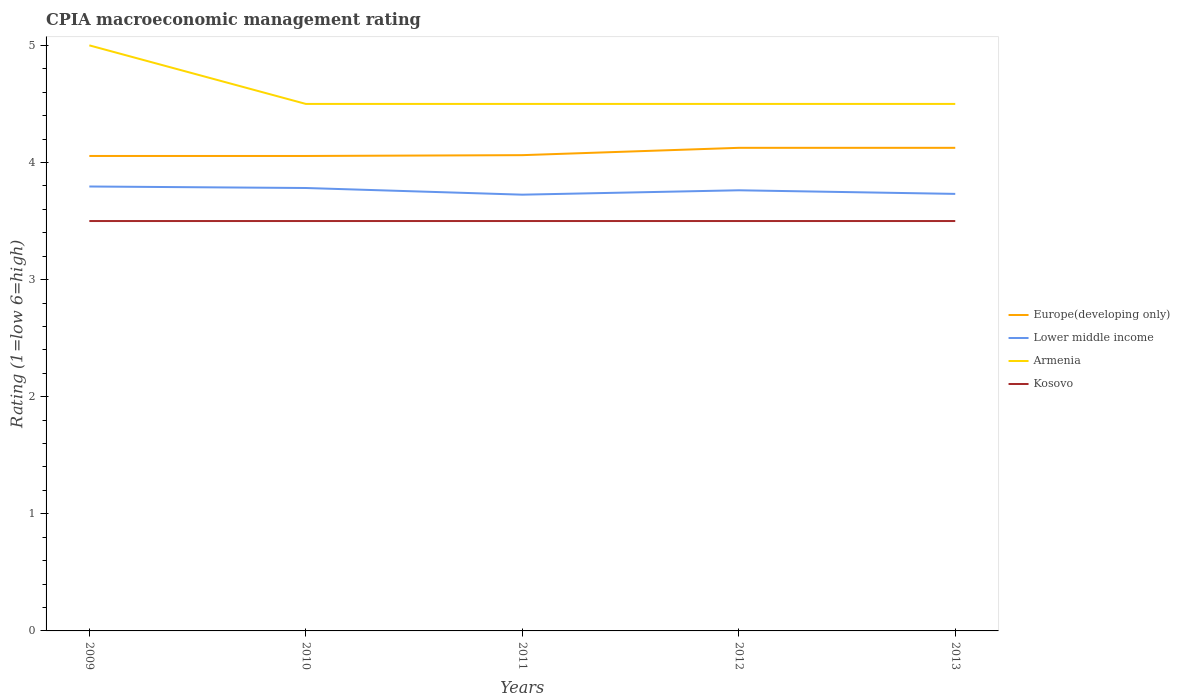Does the line corresponding to Kosovo intersect with the line corresponding to Lower middle income?
Provide a succinct answer. No. Is the number of lines equal to the number of legend labels?
Keep it short and to the point. Yes. Across all years, what is the maximum CPIA rating in Lower middle income?
Offer a terse response. 3.73. What is the difference between the highest and the second highest CPIA rating in Europe(developing only)?
Your response must be concise. 0.07. How many lines are there?
Your answer should be compact. 4. How many years are there in the graph?
Your answer should be very brief. 5. What is the difference between two consecutive major ticks on the Y-axis?
Give a very brief answer. 1. Are the values on the major ticks of Y-axis written in scientific E-notation?
Make the answer very short. No. Does the graph contain any zero values?
Offer a terse response. No. Does the graph contain grids?
Give a very brief answer. No. Where does the legend appear in the graph?
Give a very brief answer. Center right. What is the title of the graph?
Keep it short and to the point. CPIA macroeconomic management rating. What is the label or title of the Y-axis?
Your answer should be compact. Rating (1=low 6=high). What is the Rating (1=low 6=high) in Europe(developing only) in 2009?
Provide a succinct answer. 4.06. What is the Rating (1=low 6=high) of Lower middle income in 2009?
Your answer should be compact. 3.79. What is the Rating (1=low 6=high) of Europe(developing only) in 2010?
Keep it short and to the point. 4.06. What is the Rating (1=low 6=high) of Lower middle income in 2010?
Your answer should be compact. 3.78. What is the Rating (1=low 6=high) in Europe(developing only) in 2011?
Ensure brevity in your answer.  4.06. What is the Rating (1=low 6=high) in Lower middle income in 2011?
Your response must be concise. 3.73. What is the Rating (1=low 6=high) in Armenia in 2011?
Your response must be concise. 4.5. What is the Rating (1=low 6=high) of Europe(developing only) in 2012?
Your answer should be compact. 4.12. What is the Rating (1=low 6=high) in Lower middle income in 2012?
Provide a short and direct response. 3.76. What is the Rating (1=low 6=high) in Armenia in 2012?
Make the answer very short. 4.5. What is the Rating (1=low 6=high) in Kosovo in 2012?
Ensure brevity in your answer.  3.5. What is the Rating (1=low 6=high) in Europe(developing only) in 2013?
Make the answer very short. 4.12. What is the Rating (1=low 6=high) in Lower middle income in 2013?
Your answer should be compact. 3.73. What is the Rating (1=low 6=high) in Armenia in 2013?
Offer a terse response. 4.5. What is the Rating (1=low 6=high) of Kosovo in 2013?
Your answer should be compact. 3.5. Across all years, what is the maximum Rating (1=low 6=high) of Europe(developing only)?
Your response must be concise. 4.12. Across all years, what is the maximum Rating (1=low 6=high) of Lower middle income?
Give a very brief answer. 3.79. Across all years, what is the maximum Rating (1=low 6=high) of Kosovo?
Your answer should be very brief. 3.5. Across all years, what is the minimum Rating (1=low 6=high) in Europe(developing only)?
Make the answer very short. 4.06. Across all years, what is the minimum Rating (1=low 6=high) in Lower middle income?
Your response must be concise. 3.73. Across all years, what is the minimum Rating (1=low 6=high) in Armenia?
Offer a terse response. 4.5. Across all years, what is the minimum Rating (1=low 6=high) in Kosovo?
Keep it short and to the point. 3.5. What is the total Rating (1=low 6=high) of Europe(developing only) in the graph?
Provide a succinct answer. 20.42. What is the total Rating (1=low 6=high) of Lower middle income in the graph?
Your answer should be compact. 18.8. What is the total Rating (1=low 6=high) in Armenia in the graph?
Keep it short and to the point. 23. What is the difference between the Rating (1=low 6=high) in Europe(developing only) in 2009 and that in 2010?
Offer a very short reply. 0. What is the difference between the Rating (1=low 6=high) in Lower middle income in 2009 and that in 2010?
Your answer should be compact. 0.01. What is the difference between the Rating (1=low 6=high) in Armenia in 2009 and that in 2010?
Give a very brief answer. 0.5. What is the difference between the Rating (1=low 6=high) of Kosovo in 2009 and that in 2010?
Your response must be concise. 0. What is the difference between the Rating (1=low 6=high) in Europe(developing only) in 2009 and that in 2011?
Give a very brief answer. -0.01. What is the difference between the Rating (1=low 6=high) of Lower middle income in 2009 and that in 2011?
Make the answer very short. 0.07. What is the difference between the Rating (1=low 6=high) of Armenia in 2009 and that in 2011?
Your answer should be very brief. 0.5. What is the difference between the Rating (1=low 6=high) of Europe(developing only) in 2009 and that in 2012?
Offer a very short reply. -0.07. What is the difference between the Rating (1=low 6=high) of Lower middle income in 2009 and that in 2012?
Your answer should be compact. 0.03. What is the difference between the Rating (1=low 6=high) in Europe(developing only) in 2009 and that in 2013?
Offer a terse response. -0.07. What is the difference between the Rating (1=low 6=high) of Lower middle income in 2009 and that in 2013?
Give a very brief answer. 0.06. What is the difference between the Rating (1=low 6=high) of Europe(developing only) in 2010 and that in 2011?
Offer a very short reply. -0.01. What is the difference between the Rating (1=low 6=high) of Lower middle income in 2010 and that in 2011?
Ensure brevity in your answer.  0.06. What is the difference between the Rating (1=low 6=high) in Europe(developing only) in 2010 and that in 2012?
Your answer should be compact. -0.07. What is the difference between the Rating (1=low 6=high) in Lower middle income in 2010 and that in 2012?
Your answer should be compact. 0.02. What is the difference between the Rating (1=low 6=high) of Armenia in 2010 and that in 2012?
Provide a short and direct response. 0. What is the difference between the Rating (1=low 6=high) of Europe(developing only) in 2010 and that in 2013?
Your answer should be compact. -0.07. What is the difference between the Rating (1=low 6=high) of Lower middle income in 2010 and that in 2013?
Give a very brief answer. 0.05. What is the difference between the Rating (1=low 6=high) of Armenia in 2010 and that in 2013?
Make the answer very short. 0. What is the difference between the Rating (1=low 6=high) of Europe(developing only) in 2011 and that in 2012?
Keep it short and to the point. -0.06. What is the difference between the Rating (1=low 6=high) of Lower middle income in 2011 and that in 2012?
Keep it short and to the point. -0.04. What is the difference between the Rating (1=low 6=high) in Armenia in 2011 and that in 2012?
Your answer should be compact. 0. What is the difference between the Rating (1=low 6=high) of Europe(developing only) in 2011 and that in 2013?
Keep it short and to the point. -0.06. What is the difference between the Rating (1=low 6=high) in Lower middle income in 2011 and that in 2013?
Make the answer very short. -0.01. What is the difference between the Rating (1=low 6=high) in Lower middle income in 2012 and that in 2013?
Your answer should be compact. 0.03. What is the difference between the Rating (1=low 6=high) in Armenia in 2012 and that in 2013?
Keep it short and to the point. 0. What is the difference between the Rating (1=low 6=high) in Kosovo in 2012 and that in 2013?
Your response must be concise. 0. What is the difference between the Rating (1=low 6=high) of Europe(developing only) in 2009 and the Rating (1=low 6=high) of Lower middle income in 2010?
Your answer should be compact. 0.27. What is the difference between the Rating (1=low 6=high) of Europe(developing only) in 2009 and the Rating (1=low 6=high) of Armenia in 2010?
Keep it short and to the point. -0.44. What is the difference between the Rating (1=low 6=high) of Europe(developing only) in 2009 and the Rating (1=low 6=high) of Kosovo in 2010?
Provide a succinct answer. 0.56. What is the difference between the Rating (1=low 6=high) of Lower middle income in 2009 and the Rating (1=low 6=high) of Armenia in 2010?
Make the answer very short. -0.71. What is the difference between the Rating (1=low 6=high) in Lower middle income in 2009 and the Rating (1=low 6=high) in Kosovo in 2010?
Keep it short and to the point. 0.29. What is the difference between the Rating (1=low 6=high) of Europe(developing only) in 2009 and the Rating (1=low 6=high) of Lower middle income in 2011?
Provide a short and direct response. 0.33. What is the difference between the Rating (1=low 6=high) of Europe(developing only) in 2009 and the Rating (1=low 6=high) of Armenia in 2011?
Provide a succinct answer. -0.44. What is the difference between the Rating (1=low 6=high) of Europe(developing only) in 2009 and the Rating (1=low 6=high) of Kosovo in 2011?
Offer a very short reply. 0.56. What is the difference between the Rating (1=low 6=high) in Lower middle income in 2009 and the Rating (1=low 6=high) in Armenia in 2011?
Your answer should be compact. -0.71. What is the difference between the Rating (1=low 6=high) of Lower middle income in 2009 and the Rating (1=low 6=high) of Kosovo in 2011?
Make the answer very short. 0.29. What is the difference between the Rating (1=low 6=high) in Armenia in 2009 and the Rating (1=low 6=high) in Kosovo in 2011?
Make the answer very short. 1.5. What is the difference between the Rating (1=low 6=high) of Europe(developing only) in 2009 and the Rating (1=low 6=high) of Lower middle income in 2012?
Ensure brevity in your answer.  0.29. What is the difference between the Rating (1=low 6=high) in Europe(developing only) in 2009 and the Rating (1=low 6=high) in Armenia in 2012?
Offer a terse response. -0.44. What is the difference between the Rating (1=low 6=high) of Europe(developing only) in 2009 and the Rating (1=low 6=high) of Kosovo in 2012?
Your answer should be compact. 0.56. What is the difference between the Rating (1=low 6=high) of Lower middle income in 2009 and the Rating (1=low 6=high) of Armenia in 2012?
Provide a succinct answer. -0.71. What is the difference between the Rating (1=low 6=high) in Lower middle income in 2009 and the Rating (1=low 6=high) in Kosovo in 2012?
Keep it short and to the point. 0.29. What is the difference between the Rating (1=low 6=high) of Armenia in 2009 and the Rating (1=low 6=high) of Kosovo in 2012?
Make the answer very short. 1.5. What is the difference between the Rating (1=low 6=high) in Europe(developing only) in 2009 and the Rating (1=low 6=high) in Lower middle income in 2013?
Keep it short and to the point. 0.32. What is the difference between the Rating (1=low 6=high) of Europe(developing only) in 2009 and the Rating (1=low 6=high) of Armenia in 2013?
Provide a short and direct response. -0.44. What is the difference between the Rating (1=low 6=high) of Europe(developing only) in 2009 and the Rating (1=low 6=high) of Kosovo in 2013?
Provide a succinct answer. 0.56. What is the difference between the Rating (1=low 6=high) of Lower middle income in 2009 and the Rating (1=low 6=high) of Armenia in 2013?
Your response must be concise. -0.71. What is the difference between the Rating (1=low 6=high) in Lower middle income in 2009 and the Rating (1=low 6=high) in Kosovo in 2013?
Provide a short and direct response. 0.29. What is the difference between the Rating (1=low 6=high) in Armenia in 2009 and the Rating (1=low 6=high) in Kosovo in 2013?
Offer a very short reply. 1.5. What is the difference between the Rating (1=low 6=high) of Europe(developing only) in 2010 and the Rating (1=low 6=high) of Lower middle income in 2011?
Your response must be concise. 0.33. What is the difference between the Rating (1=low 6=high) in Europe(developing only) in 2010 and the Rating (1=low 6=high) in Armenia in 2011?
Offer a very short reply. -0.44. What is the difference between the Rating (1=low 6=high) in Europe(developing only) in 2010 and the Rating (1=low 6=high) in Kosovo in 2011?
Offer a very short reply. 0.56. What is the difference between the Rating (1=low 6=high) in Lower middle income in 2010 and the Rating (1=low 6=high) in Armenia in 2011?
Offer a terse response. -0.72. What is the difference between the Rating (1=low 6=high) in Lower middle income in 2010 and the Rating (1=low 6=high) in Kosovo in 2011?
Provide a succinct answer. 0.28. What is the difference between the Rating (1=low 6=high) of Armenia in 2010 and the Rating (1=low 6=high) of Kosovo in 2011?
Offer a terse response. 1. What is the difference between the Rating (1=low 6=high) in Europe(developing only) in 2010 and the Rating (1=low 6=high) in Lower middle income in 2012?
Your answer should be very brief. 0.29. What is the difference between the Rating (1=low 6=high) of Europe(developing only) in 2010 and the Rating (1=low 6=high) of Armenia in 2012?
Your answer should be very brief. -0.44. What is the difference between the Rating (1=low 6=high) in Europe(developing only) in 2010 and the Rating (1=low 6=high) in Kosovo in 2012?
Your answer should be compact. 0.56. What is the difference between the Rating (1=low 6=high) of Lower middle income in 2010 and the Rating (1=low 6=high) of Armenia in 2012?
Provide a succinct answer. -0.72. What is the difference between the Rating (1=low 6=high) of Lower middle income in 2010 and the Rating (1=low 6=high) of Kosovo in 2012?
Your answer should be very brief. 0.28. What is the difference between the Rating (1=low 6=high) of Armenia in 2010 and the Rating (1=low 6=high) of Kosovo in 2012?
Keep it short and to the point. 1. What is the difference between the Rating (1=low 6=high) of Europe(developing only) in 2010 and the Rating (1=low 6=high) of Lower middle income in 2013?
Keep it short and to the point. 0.32. What is the difference between the Rating (1=low 6=high) in Europe(developing only) in 2010 and the Rating (1=low 6=high) in Armenia in 2013?
Provide a succinct answer. -0.44. What is the difference between the Rating (1=low 6=high) of Europe(developing only) in 2010 and the Rating (1=low 6=high) of Kosovo in 2013?
Make the answer very short. 0.56. What is the difference between the Rating (1=low 6=high) of Lower middle income in 2010 and the Rating (1=low 6=high) of Armenia in 2013?
Your answer should be compact. -0.72. What is the difference between the Rating (1=low 6=high) of Lower middle income in 2010 and the Rating (1=low 6=high) of Kosovo in 2013?
Offer a terse response. 0.28. What is the difference between the Rating (1=low 6=high) in Armenia in 2010 and the Rating (1=low 6=high) in Kosovo in 2013?
Offer a very short reply. 1. What is the difference between the Rating (1=low 6=high) in Europe(developing only) in 2011 and the Rating (1=low 6=high) in Lower middle income in 2012?
Your response must be concise. 0.3. What is the difference between the Rating (1=low 6=high) of Europe(developing only) in 2011 and the Rating (1=low 6=high) of Armenia in 2012?
Provide a short and direct response. -0.44. What is the difference between the Rating (1=low 6=high) in Europe(developing only) in 2011 and the Rating (1=low 6=high) in Kosovo in 2012?
Provide a short and direct response. 0.56. What is the difference between the Rating (1=low 6=high) of Lower middle income in 2011 and the Rating (1=low 6=high) of Armenia in 2012?
Offer a terse response. -0.78. What is the difference between the Rating (1=low 6=high) in Lower middle income in 2011 and the Rating (1=low 6=high) in Kosovo in 2012?
Make the answer very short. 0.23. What is the difference between the Rating (1=low 6=high) of Europe(developing only) in 2011 and the Rating (1=low 6=high) of Lower middle income in 2013?
Your answer should be very brief. 0.33. What is the difference between the Rating (1=low 6=high) in Europe(developing only) in 2011 and the Rating (1=low 6=high) in Armenia in 2013?
Your answer should be compact. -0.44. What is the difference between the Rating (1=low 6=high) in Europe(developing only) in 2011 and the Rating (1=low 6=high) in Kosovo in 2013?
Provide a short and direct response. 0.56. What is the difference between the Rating (1=low 6=high) in Lower middle income in 2011 and the Rating (1=low 6=high) in Armenia in 2013?
Give a very brief answer. -0.78. What is the difference between the Rating (1=low 6=high) of Lower middle income in 2011 and the Rating (1=low 6=high) of Kosovo in 2013?
Offer a very short reply. 0.23. What is the difference between the Rating (1=low 6=high) in Armenia in 2011 and the Rating (1=low 6=high) in Kosovo in 2013?
Your answer should be very brief. 1. What is the difference between the Rating (1=low 6=high) in Europe(developing only) in 2012 and the Rating (1=low 6=high) in Lower middle income in 2013?
Your response must be concise. 0.39. What is the difference between the Rating (1=low 6=high) in Europe(developing only) in 2012 and the Rating (1=low 6=high) in Armenia in 2013?
Offer a terse response. -0.38. What is the difference between the Rating (1=low 6=high) in Europe(developing only) in 2012 and the Rating (1=low 6=high) in Kosovo in 2013?
Your answer should be compact. 0.62. What is the difference between the Rating (1=low 6=high) in Lower middle income in 2012 and the Rating (1=low 6=high) in Armenia in 2013?
Your response must be concise. -0.74. What is the difference between the Rating (1=low 6=high) of Lower middle income in 2012 and the Rating (1=low 6=high) of Kosovo in 2013?
Provide a succinct answer. 0.26. What is the average Rating (1=low 6=high) in Europe(developing only) per year?
Ensure brevity in your answer.  4.08. What is the average Rating (1=low 6=high) in Lower middle income per year?
Offer a terse response. 3.76. What is the average Rating (1=low 6=high) of Armenia per year?
Your answer should be very brief. 4.6. What is the average Rating (1=low 6=high) of Kosovo per year?
Offer a terse response. 3.5. In the year 2009, what is the difference between the Rating (1=low 6=high) of Europe(developing only) and Rating (1=low 6=high) of Lower middle income?
Give a very brief answer. 0.26. In the year 2009, what is the difference between the Rating (1=low 6=high) of Europe(developing only) and Rating (1=low 6=high) of Armenia?
Your answer should be very brief. -0.94. In the year 2009, what is the difference between the Rating (1=low 6=high) in Europe(developing only) and Rating (1=low 6=high) in Kosovo?
Offer a very short reply. 0.56. In the year 2009, what is the difference between the Rating (1=low 6=high) in Lower middle income and Rating (1=low 6=high) in Armenia?
Provide a succinct answer. -1.21. In the year 2009, what is the difference between the Rating (1=low 6=high) in Lower middle income and Rating (1=low 6=high) in Kosovo?
Keep it short and to the point. 0.29. In the year 2009, what is the difference between the Rating (1=low 6=high) of Armenia and Rating (1=low 6=high) of Kosovo?
Ensure brevity in your answer.  1.5. In the year 2010, what is the difference between the Rating (1=low 6=high) in Europe(developing only) and Rating (1=low 6=high) in Lower middle income?
Make the answer very short. 0.27. In the year 2010, what is the difference between the Rating (1=low 6=high) of Europe(developing only) and Rating (1=low 6=high) of Armenia?
Offer a terse response. -0.44. In the year 2010, what is the difference between the Rating (1=low 6=high) of Europe(developing only) and Rating (1=low 6=high) of Kosovo?
Keep it short and to the point. 0.56. In the year 2010, what is the difference between the Rating (1=low 6=high) in Lower middle income and Rating (1=low 6=high) in Armenia?
Your response must be concise. -0.72. In the year 2010, what is the difference between the Rating (1=low 6=high) of Lower middle income and Rating (1=low 6=high) of Kosovo?
Your answer should be very brief. 0.28. In the year 2011, what is the difference between the Rating (1=low 6=high) of Europe(developing only) and Rating (1=low 6=high) of Lower middle income?
Your answer should be compact. 0.34. In the year 2011, what is the difference between the Rating (1=low 6=high) of Europe(developing only) and Rating (1=low 6=high) of Armenia?
Provide a succinct answer. -0.44. In the year 2011, what is the difference between the Rating (1=low 6=high) in Europe(developing only) and Rating (1=low 6=high) in Kosovo?
Ensure brevity in your answer.  0.56. In the year 2011, what is the difference between the Rating (1=low 6=high) in Lower middle income and Rating (1=low 6=high) in Armenia?
Your answer should be compact. -0.78. In the year 2011, what is the difference between the Rating (1=low 6=high) of Lower middle income and Rating (1=low 6=high) of Kosovo?
Your answer should be very brief. 0.23. In the year 2012, what is the difference between the Rating (1=low 6=high) in Europe(developing only) and Rating (1=low 6=high) in Lower middle income?
Provide a short and direct response. 0.36. In the year 2012, what is the difference between the Rating (1=low 6=high) of Europe(developing only) and Rating (1=low 6=high) of Armenia?
Provide a short and direct response. -0.38. In the year 2012, what is the difference between the Rating (1=low 6=high) of Lower middle income and Rating (1=low 6=high) of Armenia?
Your response must be concise. -0.74. In the year 2012, what is the difference between the Rating (1=low 6=high) in Lower middle income and Rating (1=low 6=high) in Kosovo?
Offer a very short reply. 0.26. In the year 2012, what is the difference between the Rating (1=low 6=high) of Armenia and Rating (1=low 6=high) of Kosovo?
Your answer should be compact. 1. In the year 2013, what is the difference between the Rating (1=low 6=high) in Europe(developing only) and Rating (1=low 6=high) in Lower middle income?
Your answer should be very brief. 0.39. In the year 2013, what is the difference between the Rating (1=low 6=high) of Europe(developing only) and Rating (1=low 6=high) of Armenia?
Your answer should be very brief. -0.38. In the year 2013, what is the difference between the Rating (1=low 6=high) of Europe(developing only) and Rating (1=low 6=high) of Kosovo?
Offer a terse response. 0.62. In the year 2013, what is the difference between the Rating (1=low 6=high) of Lower middle income and Rating (1=low 6=high) of Armenia?
Your answer should be compact. -0.77. In the year 2013, what is the difference between the Rating (1=low 6=high) of Lower middle income and Rating (1=low 6=high) of Kosovo?
Provide a succinct answer. 0.23. In the year 2013, what is the difference between the Rating (1=low 6=high) of Armenia and Rating (1=low 6=high) of Kosovo?
Provide a succinct answer. 1. What is the ratio of the Rating (1=low 6=high) of Kosovo in 2009 to that in 2010?
Keep it short and to the point. 1. What is the ratio of the Rating (1=low 6=high) in Europe(developing only) in 2009 to that in 2011?
Offer a terse response. 1. What is the ratio of the Rating (1=low 6=high) in Lower middle income in 2009 to that in 2011?
Your response must be concise. 1.02. What is the ratio of the Rating (1=low 6=high) in Armenia in 2009 to that in 2011?
Offer a very short reply. 1.11. What is the ratio of the Rating (1=low 6=high) of Europe(developing only) in 2009 to that in 2012?
Your answer should be compact. 0.98. What is the ratio of the Rating (1=low 6=high) of Lower middle income in 2009 to that in 2012?
Give a very brief answer. 1.01. What is the ratio of the Rating (1=low 6=high) of Kosovo in 2009 to that in 2012?
Provide a short and direct response. 1. What is the ratio of the Rating (1=low 6=high) in Europe(developing only) in 2009 to that in 2013?
Your response must be concise. 0.98. What is the ratio of the Rating (1=low 6=high) of Lower middle income in 2009 to that in 2013?
Your answer should be compact. 1.02. What is the ratio of the Rating (1=low 6=high) of Armenia in 2009 to that in 2013?
Offer a terse response. 1.11. What is the ratio of the Rating (1=low 6=high) of Kosovo in 2009 to that in 2013?
Offer a very short reply. 1. What is the ratio of the Rating (1=low 6=high) of Lower middle income in 2010 to that in 2011?
Offer a very short reply. 1.02. What is the ratio of the Rating (1=low 6=high) of Europe(developing only) in 2010 to that in 2012?
Your response must be concise. 0.98. What is the ratio of the Rating (1=low 6=high) in Lower middle income in 2010 to that in 2012?
Provide a short and direct response. 1.01. What is the ratio of the Rating (1=low 6=high) of Europe(developing only) in 2010 to that in 2013?
Provide a succinct answer. 0.98. What is the ratio of the Rating (1=low 6=high) of Lower middle income in 2010 to that in 2013?
Provide a succinct answer. 1.01. What is the ratio of the Rating (1=low 6=high) of Armenia in 2010 to that in 2013?
Ensure brevity in your answer.  1. What is the ratio of the Rating (1=low 6=high) in Kosovo in 2010 to that in 2013?
Your answer should be compact. 1. What is the ratio of the Rating (1=low 6=high) in Europe(developing only) in 2011 to that in 2012?
Your answer should be very brief. 0.98. What is the ratio of the Rating (1=low 6=high) of Armenia in 2011 to that in 2012?
Give a very brief answer. 1. What is the ratio of the Rating (1=low 6=high) of Kosovo in 2011 to that in 2012?
Your answer should be compact. 1. What is the ratio of the Rating (1=low 6=high) in Europe(developing only) in 2011 to that in 2013?
Your answer should be very brief. 0.98. What is the ratio of the Rating (1=low 6=high) in Armenia in 2011 to that in 2013?
Ensure brevity in your answer.  1. What is the ratio of the Rating (1=low 6=high) in Europe(developing only) in 2012 to that in 2013?
Give a very brief answer. 1. What is the ratio of the Rating (1=low 6=high) of Lower middle income in 2012 to that in 2013?
Provide a succinct answer. 1.01. What is the ratio of the Rating (1=low 6=high) in Armenia in 2012 to that in 2013?
Your answer should be compact. 1. What is the difference between the highest and the second highest Rating (1=low 6=high) of Lower middle income?
Your answer should be very brief. 0.01. What is the difference between the highest and the second highest Rating (1=low 6=high) of Armenia?
Keep it short and to the point. 0.5. What is the difference between the highest and the lowest Rating (1=low 6=high) of Europe(developing only)?
Offer a terse response. 0.07. What is the difference between the highest and the lowest Rating (1=low 6=high) in Lower middle income?
Make the answer very short. 0.07. What is the difference between the highest and the lowest Rating (1=low 6=high) of Kosovo?
Provide a succinct answer. 0. 